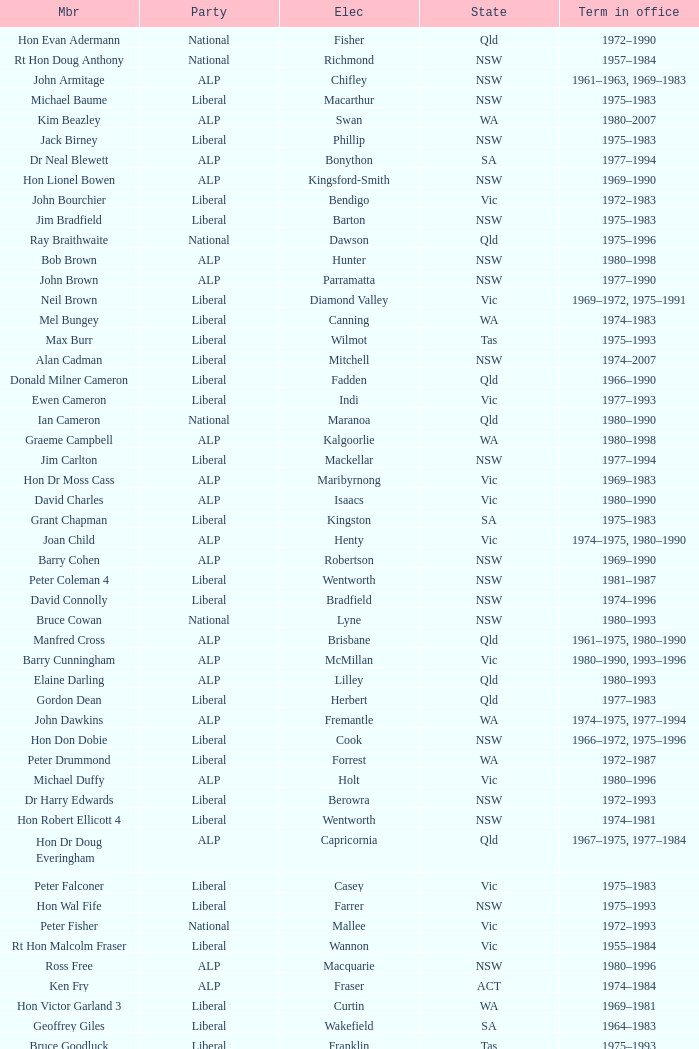When was Hon Les Johnson in office? 1955–1966, 1969–1984. 